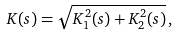Convert formula to latex. <formula><loc_0><loc_0><loc_500><loc_500>K ( s ) = \sqrt { K _ { 1 } ^ { 2 } ( s ) + K _ { 2 } ^ { 2 } ( s ) } \, ,</formula> 